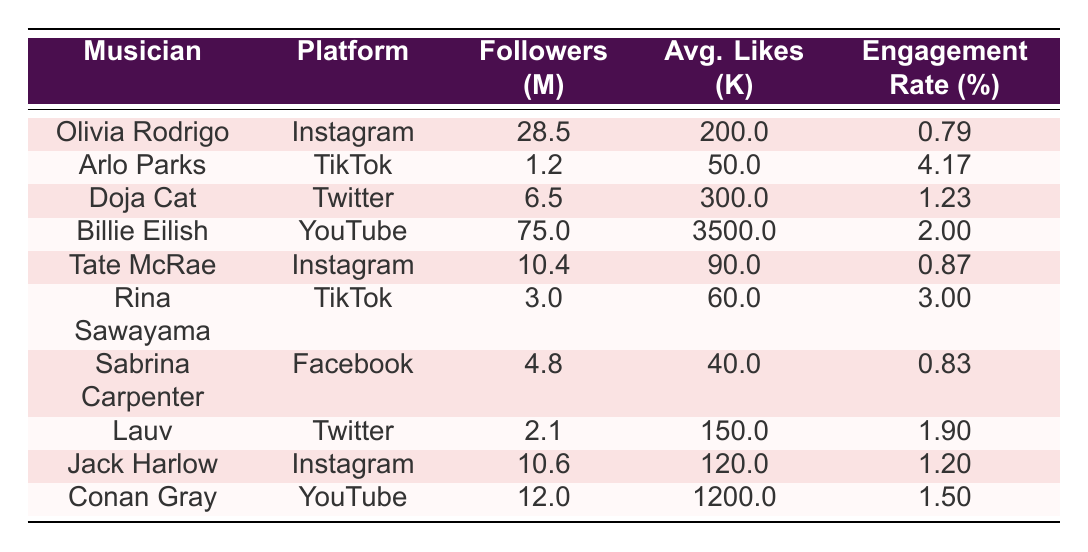What musician has the highest engagement rate? By comparing the engagement rates listed in the table, Arlo Parks has the highest engagement rate of 4.17%.
Answer: Arlo Parks Which musician has the most followers on Instagram? According to the table, Olivia Rodrigo has the most followers on Instagram with 28.5 million.
Answer: Olivia Rodrigo What is the average engagement rate for TikTok musicians? Adding the engagement rates for TikTok musicians (Arlo Parks: 4.17%, Rina Sawayama: 3.00%) gives a total of 7.17%. Dividing by 2 (the number of TikTok musicians) gives an average of 3.58%.
Answer: 3.58% Doja Cat has more average likes than Billie Eilish? Yes, Doja Cat has average likes of 300,000, while Billie Eilish has average likes of 3.5 million (or 3,500,000), which is significantly more.
Answer: No Which musician has the lowest average likes? The musician with the lowest average likes is Sabrina Carpenter with 40,000 likes on Facebook.
Answer: Sabrina Carpenter What is the difference in followers between the most followed musician and the least followed musician? The difference in followers is calculated by subtracting the least followers (1.2 million of Arlo Parks) from the most followers (75 million of Billie Eilish). So, 75 - 1.2 = 73.8 million.
Answer: 73.8 million Is Olivia Rodrigo's engagement rate higher than that of Tate McRae? Olivia Rodrigo's engagement rate is 0.79%, while Tate McRae's is 0.87%. Therefore, Tate McRae has a higher engagement rate.
Answer: No What percentage of musicians listed in the table are on Instagram? There are 4 musicians on Instagram out of a total of 10 musicians listed in the table, which is (4/10)*100 = 40%.
Answer: 40% Who has the second highest average comments among musicians? By reviewing the average comments, Billie Eilish has 7,000, and Doja Cat follows with 3,500, making Doja Cat the second highest.
Answer: Doja Cat 